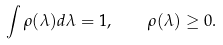<formula> <loc_0><loc_0><loc_500><loc_500>\int \rho ( \lambda ) d \lambda = 1 , \quad \rho ( \lambda ) \geq 0 .</formula> 